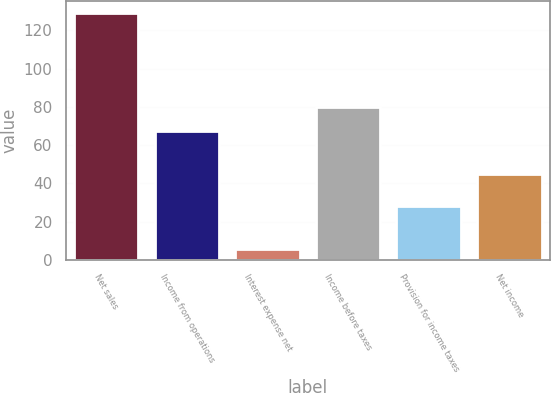Convert chart to OTSL. <chart><loc_0><loc_0><loc_500><loc_500><bar_chart><fcel>Net sales<fcel>Income from operations<fcel>Interest expense net<fcel>Income before taxes<fcel>Provision for income taxes<fcel>Net income<nl><fcel>129<fcel>67.6<fcel>5.6<fcel>79.94<fcel>28.1<fcel>45.1<nl></chart> 